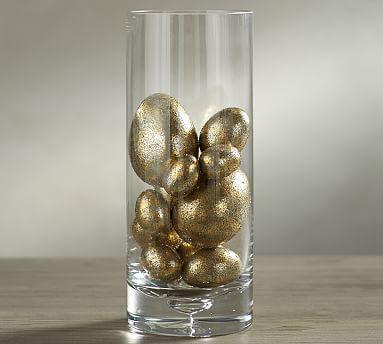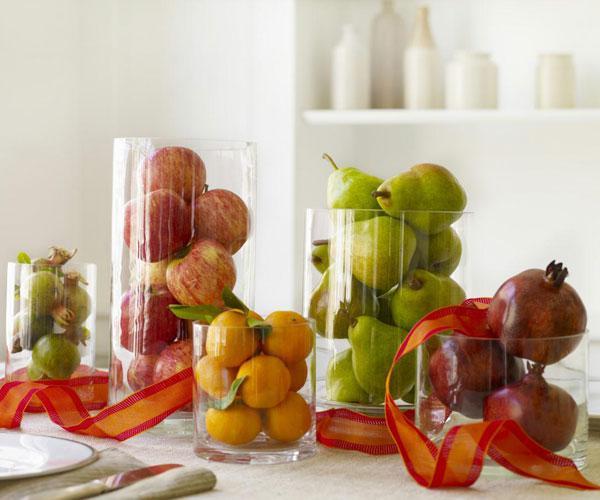The first image is the image on the left, the second image is the image on the right. Given the left and right images, does the statement "All images show exactly three glass containers containing candles and/or greenery." hold true? Answer yes or no. No. The first image is the image on the left, the second image is the image on the right. Considering the images on both sides, is "The combined images include a clear container filled with lemons and one filled with apples." valid? Answer yes or no. Yes. 